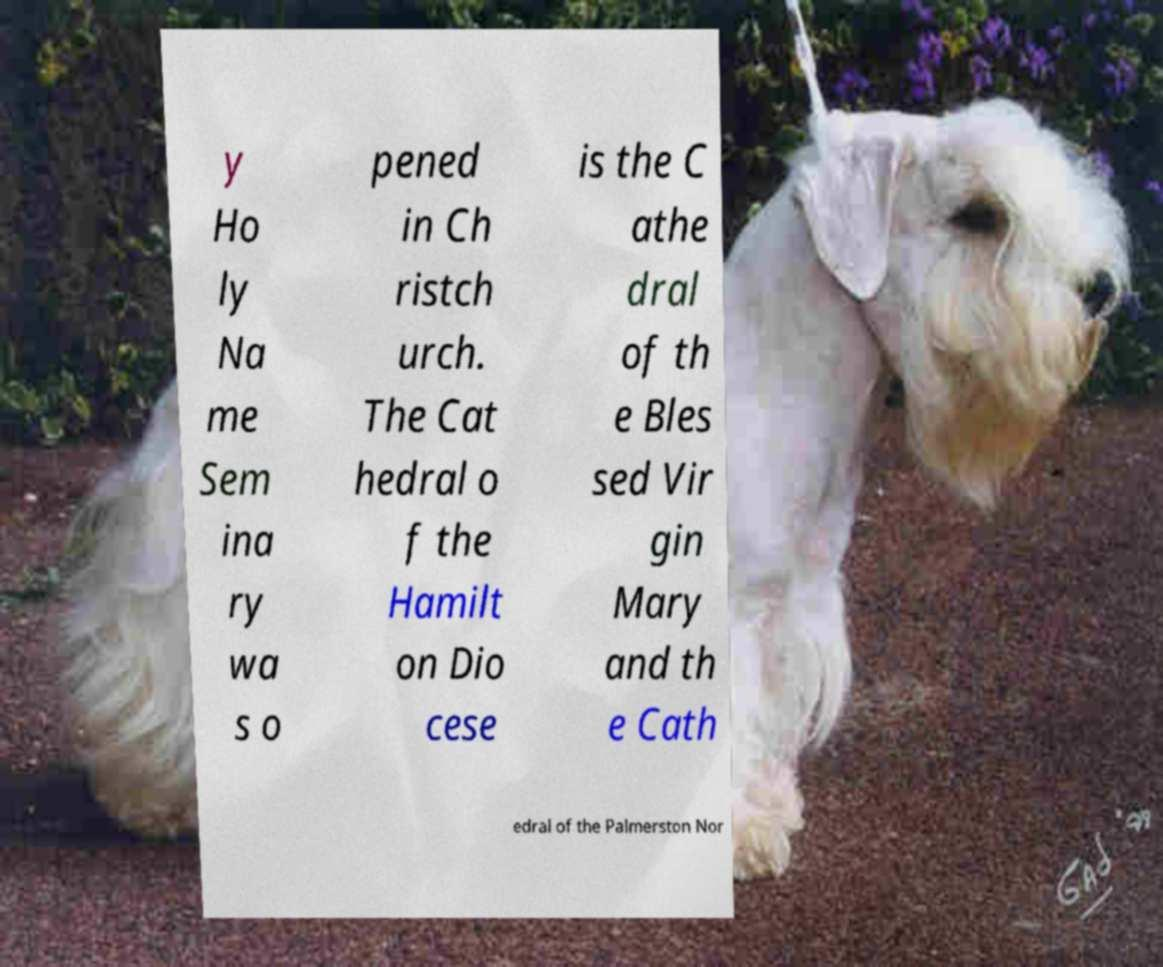What messages or text are displayed in this image? I need them in a readable, typed format. y Ho ly Na me Sem ina ry wa s o pened in Ch ristch urch. The Cat hedral o f the Hamilt on Dio cese is the C athe dral of th e Bles sed Vir gin Mary and th e Cath edral of the Palmerston Nor 